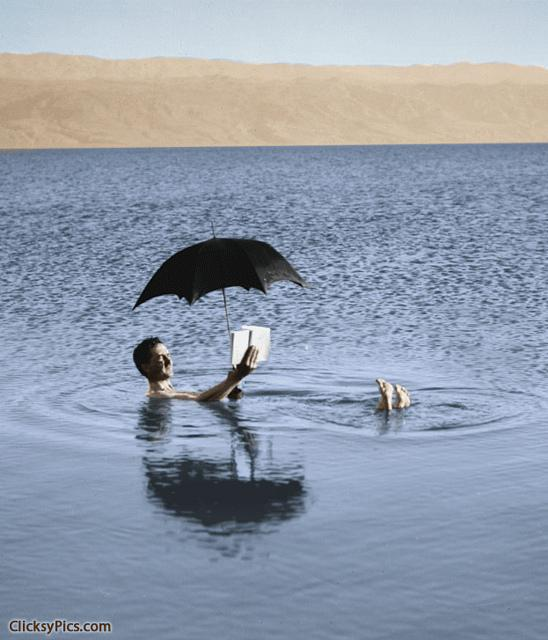Why is the man holding an umbrella? Please explain your reasoning. for shade. When you're outside on a sunny day, you want to be protected from the sunlight. 